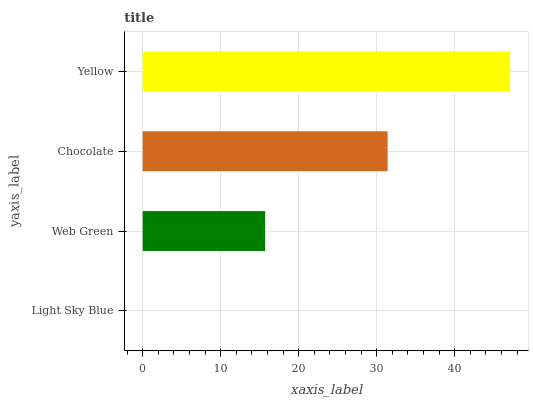Is Light Sky Blue the minimum?
Answer yes or no. Yes. Is Yellow the maximum?
Answer yes or no. Yes. Is Web Green the minimum?
Answer yes or no. No. Is Web Green the maximum?
Answer yes or no. No. Is Web Green greater than Light Sky Blue?
Answer yes or no. Yes. Is Light Sky Blue less than Web Green?
Answer yes or no. Yes. Is Light Sky Blue greater than Web Green?
Answer yes or no. No. Is Web Green less than Light Sky Blue?
Answer yes or no. No. Is Chocolate the high median?
Answer yes or no. Yes. Is Web Green the low median?
Answer yes or no. Yes. Is Yellow the high median?
Answer yes or no. No. Is Chocolate the low median?
Answer yes or no. No. 